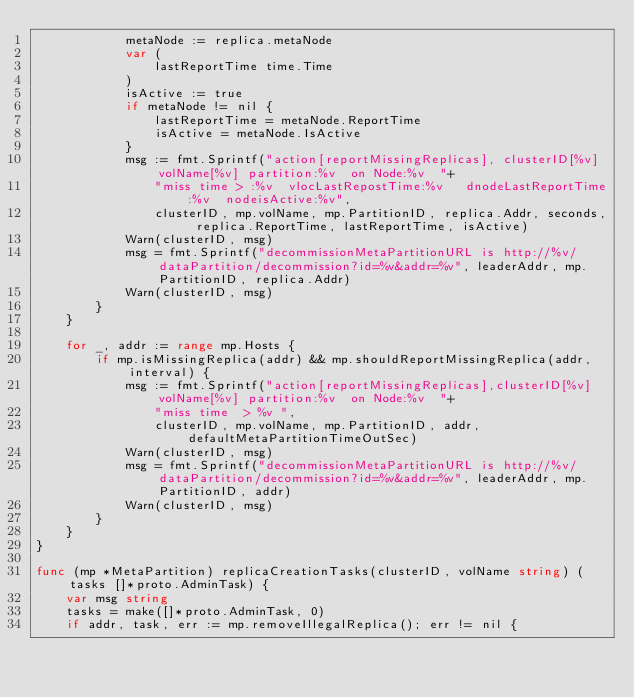<code> <loc_0><loc_0><loc_500><loc_500><_Go_>			metaNode := replica.metaNode
			var (
				lastReportTime time.Time
			)
			isActive := true
			if metaNode != nil {
				lastReportTime = metaNode.ReportTime
				isActive = metaNode.IsActive
			}
			msg := fmt.Sprintf("action[reportMissingReplicas], clusterID[%v] volName[%v] partition:%v  on Node:%v  "+
				"miss time > :%v  vlocLastRepostTime:%v   dnodeLastReportTime:%v  nodeisActive:%v",
				clusterID, mp.volName, mp.PartitionID, replica.Addr, seconds, replica.ReportTime, lastReportTime, isActive)
			Warn(clusterID, msg)
			msg = fmt.Sprintf("decommissionMetaPartitionURL is http://%v/dataPartition/decommission?id=%v&addr=%v", leaderAddr, mp.PartitionID, replica.Addr)
			Warn(clusterID, msg)
		}
	}

	for _, addr := range mp.Hosts {
		if mp.isMissingReplica(addr) && mp.shouldReportMissingReplica(addr, interval) {
			msg := fmt.Sprintf("action[reportMissingReplicas],clusterID[%v] volName[%v] partition:%v  on Node:%v  "+
				"miss time  > %v ",
				clusterID, mp.volName, mp.PartitionID, addr, defaultMetaPartitionTimeOutSec)
			Warn(clusterID, msg)
			msg = fmt.Sprintf("decommissionMetaPartitionURL is http://%v/dataPartition/decommission?id=%v&addr=%v", leaderAddr, mp.PartitionID, addr)
			Warn(clusterID, msg)
		}
	}
}

func (mp *MetaPartition) replicaCreationTasks(clusterID, volName string) (tasks []*proto.AdminTask) {
	var msg string
	tasks = make([]*proto.AdminTask, 0)
	if addr, task, err := mp.removeIllegalReplica(); err != nil {</code> 